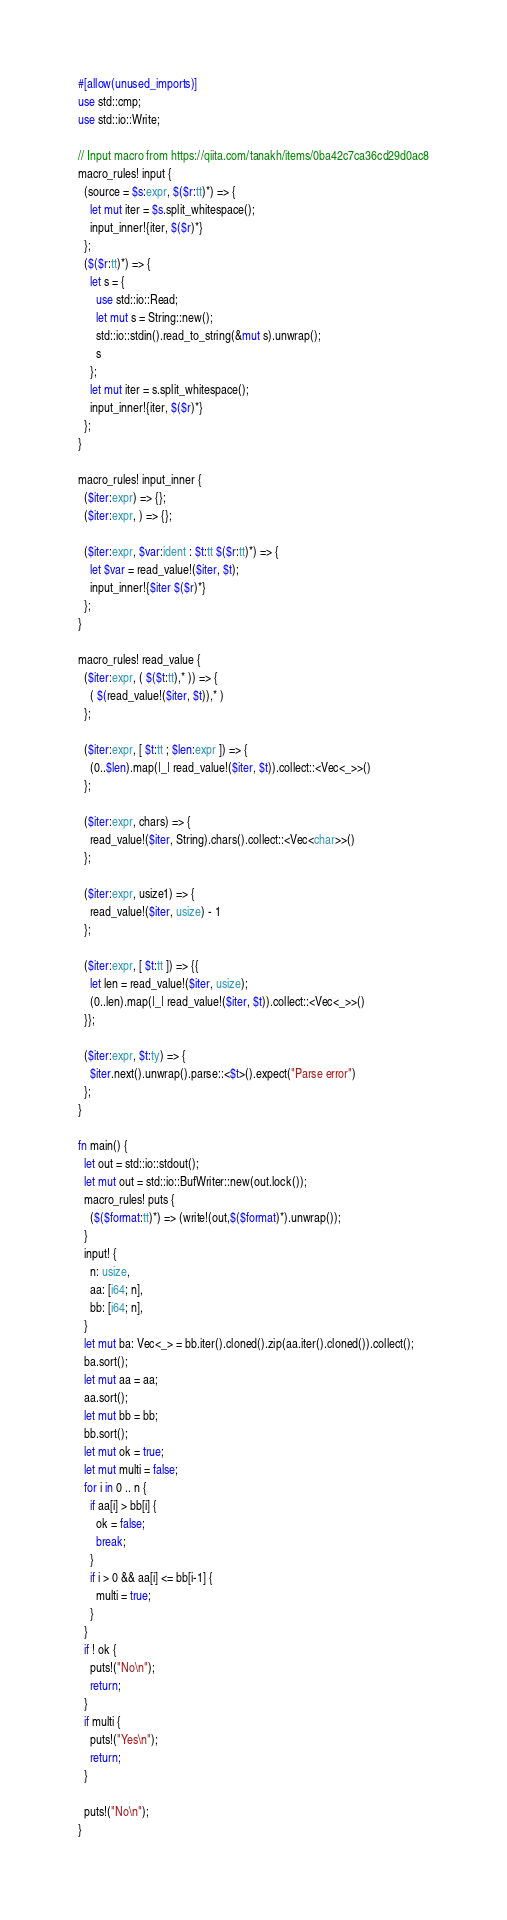<code> <loc_0><loc_0><loc_500><loc_500><_Rust_>#[allow(unused_imports)]
use std::cmp;
use std::io::Write;

// Input macro from https://qiita.com/tanakh/items/0ba42c7ca36cd29d0ac8
macro_rules! input {
  (source = $s:expr, $($r:tt)*) => {
    let mut iter = $s.split_whitespace();
    input_inner!{iter, $($r)*}
  };
  ($($r:tt)*) => {
    let s = {
      use std::io::Read;
      let mut s = String::new();
      std::io::stdin().read_to_string(&mut s).unwrap();
      s
    };
    let mut iter = s.split_whitespace();
    input_inner!{iter, $($r)*}
  };
}

macro_rules! input_inner {
  ($iter:expr) => {};
  ($iter:expr, ) => {};

  ($iter:expr, $var:ident : $t:tt $($r:tt)*) => {
    let $var = read_value!($iter, $t);
    input_inner!{$iter $($r)*}
  };
}

macro_rules! read_value {
  ($iter:expr, ( $($t:tt),* )) => {
    ( $(read_value!($iter, $t)),* )
  };

  ($iter:expr, [ $t:tt ; $len:expr ]) => {
    (0..$len).map(|_| read_value!($iter, $t)).collect::<Vec<_>>()
  };

  ($iter:expr, chars) => {
    read_value!($iter, String).chars().collect::<Vec<char>>()
  };

  ($iter:expr, usize1) => {
    read_value!($iter, usize) - 1
  };

  ($iter:expr, [ $t:tt ]) => {{
    let len = read_value!($iter, usize);
    (0..len).map(|_| read_value!($iter, $t)).collect::<Vec<_>>()
  }};

  ($iter:expr, $t:ty) => {
    $iter.next().unwrap().parse::<$t>().expect("Parse error")
  };
}

fn main() {
  let out = std::io::stdout();
  let mut out = std::io::BufWriter::new(out.lock());
  macro_rules! puts {
    ($($format:tt)*) => (write!(out,$($format)*).unwrap());
  }
  input! {
    n: usize,
    aa: [i64; n],
    bb: [i64; n],
  }
  let mut ba: Vec<_> = bb.iter().cloned().zip(aa.iter().cloned()).collect();
  ba.sort();
  let mut aa = aa;
  aa.sort();
  let mut bb = bb;
  bb.sort();
  let mut ok = true;
  let mut multi = false;
  for i in 0 .. n {
    if aa[i] > bb[i] {
      ok = false;
      break;
    }
    if i > 0 && aa[i] <= bb[i-1] {
      multi = true;
    }
  }
  if ! ok {
    puts!("No\n");
    return;
  }
  if multi {
    puts!("Yes\n");
    return;
  }

  puts!("No\n");
}
</code> 